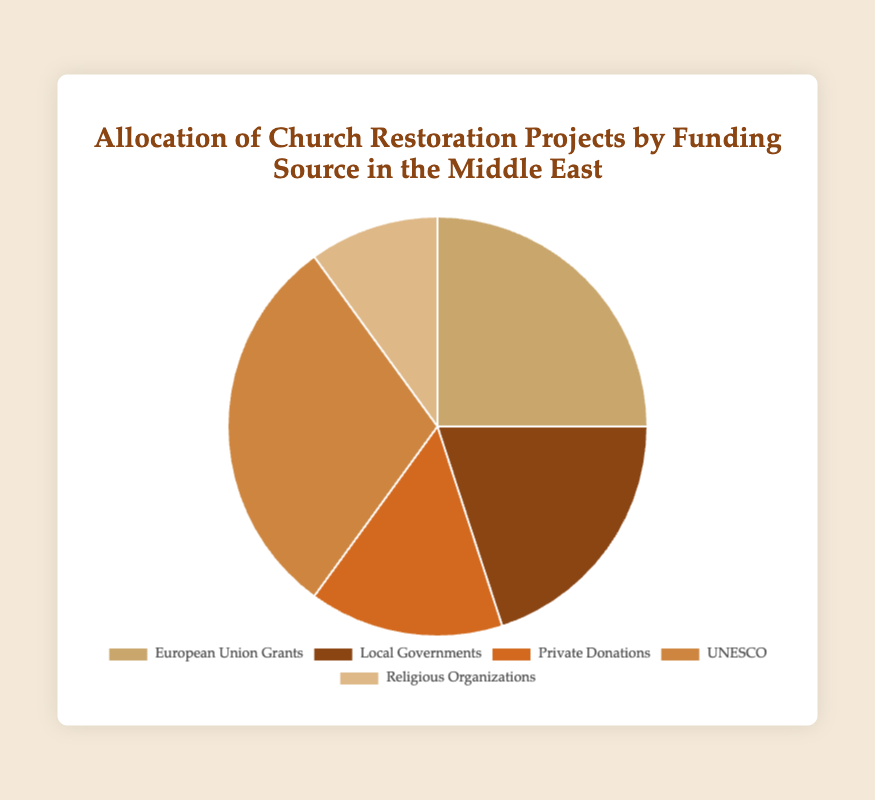Which funding source contributes the largest percentage to church restoration projects in the Middle East? By looking at the pie chart, the segment that represents the largest portion of the circle is labeled 'UNESCO' with a percentage of 30%.
Answer: UNESCO Which funding source contributes the smallest percentage to church restoration projects in the Middle East? The smallest portion of the pie chart is labeled 'Religious Organizations' with a percentage of 10%.
Answer: Religious Organizations What is the combined percentage of funding from 'Local Governments' and 'Private Donations'? The pie chart shows 'Local Governments' at 20% and 'Private Donations' at 15%. Adding these together, 20 + 15 = 35%.
Answer: 35% How much greater is the contribution from 'European Union Grants' compared to 'Religious Organizations'? 'European Union Grants' is 25%, and 'Religious Organizations' is 10%. The difference is 25 - 10 = 15%.
Answer: 15% What is the average percentage contribution of all the funding sources? The total contribution from all sources is: 25% (EU) + 20% (Local Governments) + 15% (Private Donations) + 30% (UNESCO) + 10% (Religious Organizations) = 100%. There are 5 sources, so average = 100% / 5 = 20%.
Answer: 20% Which funding sources contribute more than 20% each to church restoration projects? By examining the pie chart, 'European Union Grants' (25%) and 'UNESCO' (30%) both exceed 20%.
Answer: European Union Grants, UNESCO What is the difference in percentage between the contributions of 'UNESCO' and 'Local Governments'? According to the pie chart, 'UNESCO' contributes 30% and 'Local Governments' contribute 20%. The difference is 30 - 20 = 10%.
Answer: 10% What percentage of funding comes from non-governmental sources? Non-governmental sources in the figure are 'Private Donations', 'UNESCO', and 'Religious Organizations'. Their combined contribution is 15% (Private Donations) + 30% (UNESCO) + 10% (Religious Organizations) = 55%.
Answer: 55% Which segment is visually represented with the darkest color, and what is its contribution percentage? By visual inspection of the pie chart, the segment with the darkest color corresponds to 'Local Governments', which contributes 20%.
Answer: Local Governments, 20% 